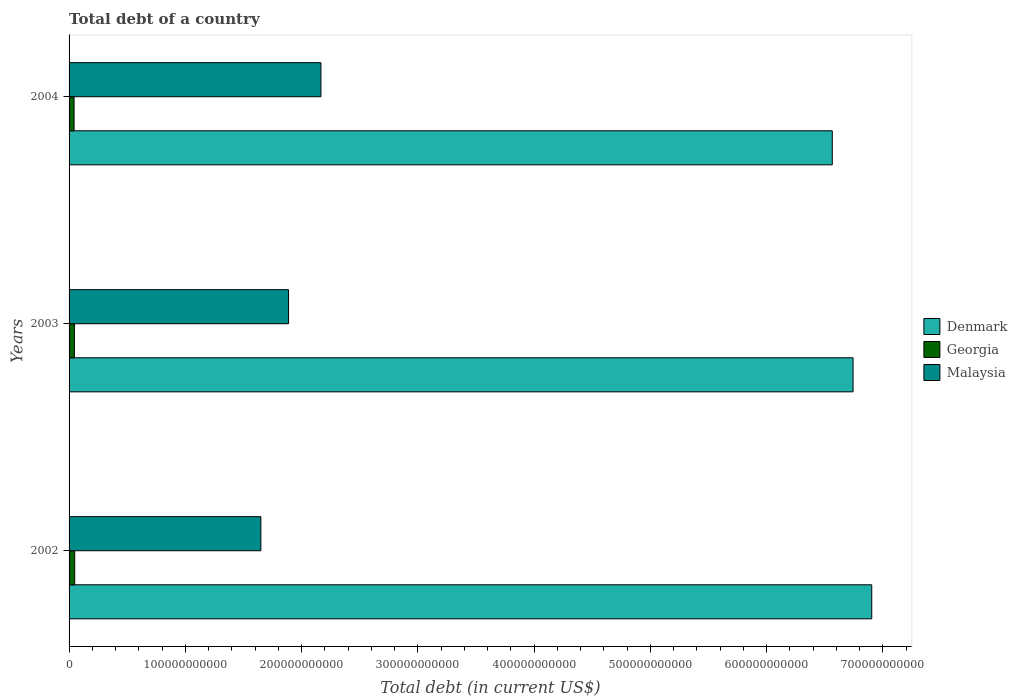How many different coloured bars are there?
Make the answer very short. 3. How many groups of bars are there?
Your answer should be compact. 3. Are the number of bars per tick equal to the number of legend labels?
Your answer should be compact. Yes. How many bars are there on the 1st tick from the top?
Ensure brevity in your answer.  3. In how many cases, is the number of bars for a given year not equal to the number of legend labels?
Your response must be concise. 0. What is the debt in Malaysia in 2003?
Keep it short and to the point. 1.89e+11. Across all years, what is the maximum debt in Denmark?
Give a very brief answer. 6.90e+11. Across all years, what is the minimum debt in Georgia?
Make the answer very short. 4.31e+09. What is the total debt in Georgia in the graph?
Your response must be concise. 1.38e+1. What is the difference between the debt in Georgia in 2003 and that in 2004?
Your response must be concise. 3.01e+08. What is the difference between the debt in Malaysia in 2004 and the debt in Denmark in 2003?
Offer a very short reply. -4.58e+11. What is the average debt in Denmark per year?
Ensure brevity in your answer.  6.74e+11. In the year 2002, what is the difference between the debt in Georgia and debt in Denmark?
Make the answer very short. -6.86e+11. In how many years, is the debt in Georgia greater than 40000000000 US$?
Give a very brief answer. 0. What is the ratio of the debt in Denmark in 2002 to that in 2004?
Your response must be concise. 1.05. Is the debt in Denmark in 2003 less than that in 2004?
Keep it short and to the point. No. What is the difference between the highest and the second highest debt in Denmark?
Give a very brief answer. 1.61e+1. What is the difference between the highest and the lowest debt in Malaysia?
Make the answer very short. 5.17e+1. In how many years, is the debt in Denmark greater than the average debt in Denmark taken over all years?
Keep it short and to the point. 2. Is the sum of the debt in Malaysia in 2002 and 2004 greater than the maximum debt in Georgia across all years?
Your answer should be compact. Yes. What does the 3rd bar from the bottom in 2004 represents?
Give a very brief answer. Malaysia. How many bars are there?
Provide a succinct answer. 9. What is the difference between two consecutive major ticks on the X-axis?
Provide a short and direct response. 1.00e+11. Are the values on the major ticks of X-axis written in scientific E-notation?
Make the answer very short. No. Does the graph contain any zero values?
Provide a short and direct response. No. Does the graph contain grids?
Ensure brevity in your answer.  No. How many legend labels are there?
Keep it short and to the point. 3. What is the title of the graph?
Provide a short and direct response. Total debt of a country. What is the label or title of the X-axis?
Offer a very short reply. Total debt (in current US$). What is the label or title of the Y-axis?
Give a very brief answer. Years. What is the Total debt (in current US$) in Denmark in 2002?
Keep it short and to the point. 6.90e+11. What is the Total debt (in current US$) in Georgia in 2002?
Keep it short and to the point. 4.84e+09. What is the Total debt (in current US$) of Malaysia in 2002?
Your answer should be compact. 1.65e+11. What is the Total debt (in current US$) in Denmark in 2003?
Offer a terse response. 6.74e+11. What is the Total debt (in current US$) in Georgia in 2003?
Keep it short and to the point. 4.61e+09. What is the Total debt (in current US$) of Malaysia in 2003?
Your answer should be compact. 1.89e+11. What is the Total debt (in current US$) of Denmark in 2004?
Ensure brevity in your answer.  6.56e+11. What is the Total debt (in current US$) in Georgia in 2004?
Your answer should be very brief. 4.31e+09. What is the Total debt (in current US$) of Malaysia in 2004?
Your answer should be very brief. 2.17e+11. Across all years, what is the maximum Total debt (in current US$) in Denmark?
Your response must be concise. 6.90e+11. Across all years, what is the maximum Total debt (in current US$) of Georgia?
Keep it short and to the point. 4.84e+09. Across all years, what is the maximum Total debt (in current US$) of Malaysia?
Offer a terse response. 2.17e+11. Across all years, what is the minimum Total debt (in current US$) in Denmark?
Offer a very short reply. 6.56e+11. Across all years, what is the minimum Total debt (in current US$) in Georgia?
Make the answer very short. 4.31e+09. Across all years, what is the minimum Total debt (in current US$) of Malaysia?
Provide a succinct answer. 1.65e+11. What is the total Total debt (in current US$) in Denmark in the graph?
Provide a short and direct response. 2.02e+12. What is the total Total debt (in current US$) of Georgia in the graph?
Make the answer very short. 1.38e+1. What is the total Total debt (in current US$) of Malaysia in the graph?
Your response must be concise. 5.70e+11. What is the difference between the Total debt (in current US$) of Denmark in 2002 and that in 2003?
Make the answer very short. 1.61e+1. What is the difference between the Total debt (in current US$) of Georgia in 2002 and that in 2003?
Offer a very short reply. 2.35e+08. What is the difference between the Total debt (in current US$) in Malaysia in 2002 and that in 2003?
Ensure brevity in your answer.  -2.38e+1. What is the difference between the Total debt (in current US$) in Denmark in 2002 and that in 2004?
Your answer should be very brief. 3.39e+1. What is the difference between the Total debt (in current US$) in Georgia in 2002 and that in 2004?
Keep it short and to the point. 5.37e+08. What is the difference between the Total debt (in current US$) in Malaysia in 2002 and that in 2004?
Provide a succinct answer. -5.17e+1. What is the difference between the Total debt (in current US$) of Denmark in 2003 and that in 2004?
Your answer should be compact. 1.79e+1. What is the difference between the Total debt (in current US$) of Georgia in 2003 and that in 2004?
Your answer should be very brief. 3.01e+08. What is the difference between the Total debt (in current US$) in Malaysia in 2003 and that in 2004?
Give a very brief answer. -2.79e+1. What is the difference between the Total debt (in current US$) in Denmark in 2002 and the Total debt (in current US$) in Georgia in 2003?
Your response must be concise. 6.86e+11. What is the difference between the Total debt (in current US$) in Denmark in 2002 and the Total debt (in current US$) in Malaysia in 2003?
Keep it short and to the point. 5.02e+11. What is the difference between the Total debt (in current US$) of Georgia in 2002 and the Total debt (in current US$) of Malaysia in 2003?
Keep it short and to the point. -1.84e+11. What is the difference between the Total debt (in current US$) in Denmark in 2002 and the Total debt (in current US$) in Georgia in 2004?
Provide a succinct answer. 6.86e+11. What is the difference between the Total debt (in current US$) of Denmark in 2002 and the Total debt (in current US$) of Malaysia in 2004?
Offer a very short reply. 4.74e+11. What is the difference between the Total debt (in current US$) of Georgia in 2002 and the Total debt (in current US$) of Malaysia in 2004?
Your answer should be compact. -2.12e+11. What is the difference between the Total debt (in current US$) in Denmark in 2003 and the Total debt (in current US$) in Georgia in 2004?
Ensure brevity in your answer.  6.70e+11. What is the difference between the Total debt (in current US$) in Denmark in 2003 and the Total debt (in current US$) in Malaysia in 2004?
Your response must be concise. 4.58e+11. What is the difference between the Total debt (in current US$) in Georgia in 2003 and the Total debt (in current US$) in Malaysia in 2004?
Offer a very short reply. -2.12e+11. What is the average Total debt (in current US$) in Denmark per year?
Keep it short and to the point. 6.74e+11. What is the average Total debt (in current US$) of Georgia per year?
Your response must be concise. 4.59e+09. What is the average Total debt (in current US$) in Malaysia per year?
Make the answer very short. 1.90e+11. In the year 2002, what is the difference between the Total debt (in current US$) of Denmark and Total debt (in current US$) of Georgia?
Make the answer very short. 6.86e+11. In the year 2002, what is the difference between the Total debt (in current US$) of Denmark and Total debt (in current US$) of Malaysia?
Your response must be concise. 5.25e+11. In the year 2002, what is the difference between the Total debt (in current US$) of Georgia and Total debt (in current US$) of Malaysia?
Offer a very short reply. -1.60e+11. In the year 2003, what is the difference between the Total debt (in current US$) in Denmark and Total debt (in current US$) in Georgia?
Ensure brevity in your answer.  6.70e+11. In the year 2003, what is the difference between the Total debt (in current US$) in Denmark and Total debt (in current US$) in Malaysia?
Make the answer very short. 4.86e+11. In the year 2003, what is the difference between the Total debt (in current US$) of Georgia and Total debt (in current US$) of Malaysia?
Your answer should be compact. -1.84e+11. In the year 2004, what is the difference between the Total debt (in current US$) in Denmark and Total debt (in current US$) in Georgia?
Keep it short and to the point. 6.52e+11. In the year 2004, what is the difference between the Total debt (in current US$) of Denmark and Total debt (in current US$) of Malaysia?
Your response must be concise. 4.40e+11. In the year 2004, what is the difference between the Total debt (in current US$) in Georgia and Total debt (in current US$) in Malaysia?
Ensure brevity in your answer.  -2.12e+11. What is the ratio of the Total debt (in current US$) in Denmark in 2002 to that in 2003?
Give a very brief answer. 1.02. What is the ratio of the Total debt (in current US$) in Georgia in 2002 to that in 2003?
Your response must be concise. 1.05. What is the ratio of the Total debt (in current US$) of Malaysia in 2002 to that in 2003?
Offer a terse response. 0.87. What is the ratio of the Total debt (in current US$) in Denmark in 2002 to that in 2004?
Offer a terse response. 1.05. What is the ratio of the Total debt (in current US$) of Georgia in 2002 to that in 2004?
Give a very brief answer. 1.12. What is the ratio of the Total debt (in current US$) of Malaysia in 2002 to that in 2004?
Make the answer very short. 0.76. What is the ratio of the Total debt (in current US$) of Denmark in 2003 to that in 2004?
Your response must be concise. 1.03. What is the ratio of the Total debt (in current US$) of Georgia in 2003 to that in 2004?
Give a very brief answer. 1.07. What is the ratio of the Total debt (in current US$) of Malaysia in 2003 to that in 2004?
Your answer should be compact. 0.87. What is the difference between the highest and the second highest Total debt (in current US$) in Denmark?
Your answer should be very brief. 1.61e+1. What is the difference between the highest and the second highest Total debt (in current US$) of Georgia?
Offer a very short reply. 2.35e+08. What is the difference between the highest and the second highest Total debt (in current US$) in Malaysia?
Make the answer very short. 2.79e+1. What is the difference between the highest and the lowest Total debt (in current US$) in Denmark?
Keep it short and to the point. 3.39e+1. What is the difference between the highest and the lowest Total debt (in current US$) in Georgia?
Offer a terse response. 5.37e+08. What is the difference between the highest and the lowest Total debt (in current US$) in Malaysia?
Make the answer very short. 5.17e+1. 